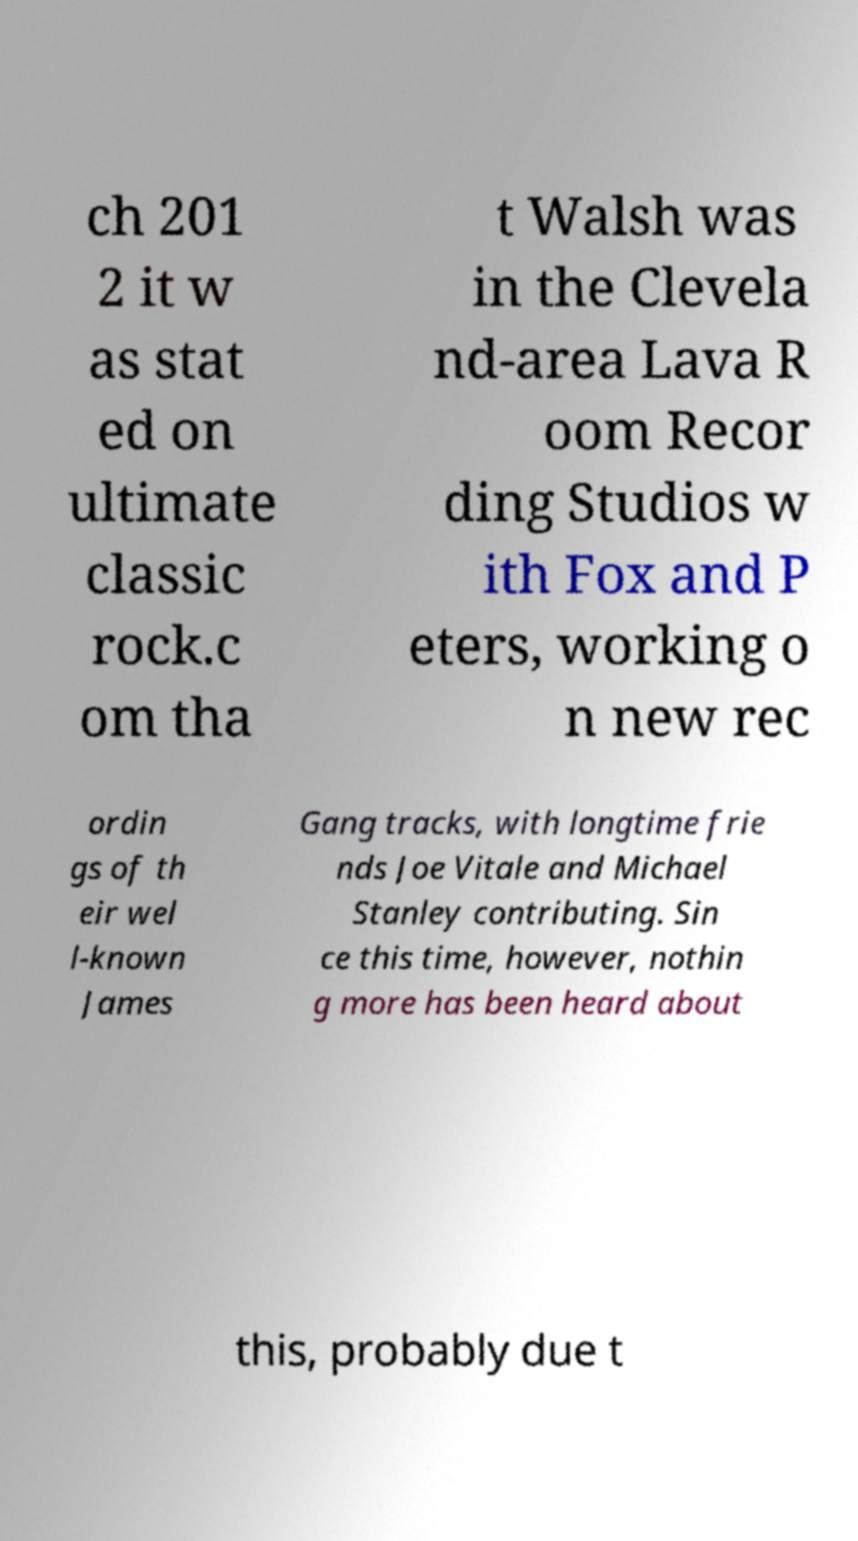Could you assist in decoding the text presented in this image and type it out clearly? ch 201 2 it w as stat ed on ultimate classic rock.c om tha t Walsh was in the Clevela nd-area Lava R oom Recor ding Studios w ith Fox and P eters, working o n new rec ordin gs of th eir wel l-known James Gang tracks, with longtime frie nds Joe Vitale and Michael Stanley contributing. Sin ce this time, however, nothin g more has been heard about this, probably due t 